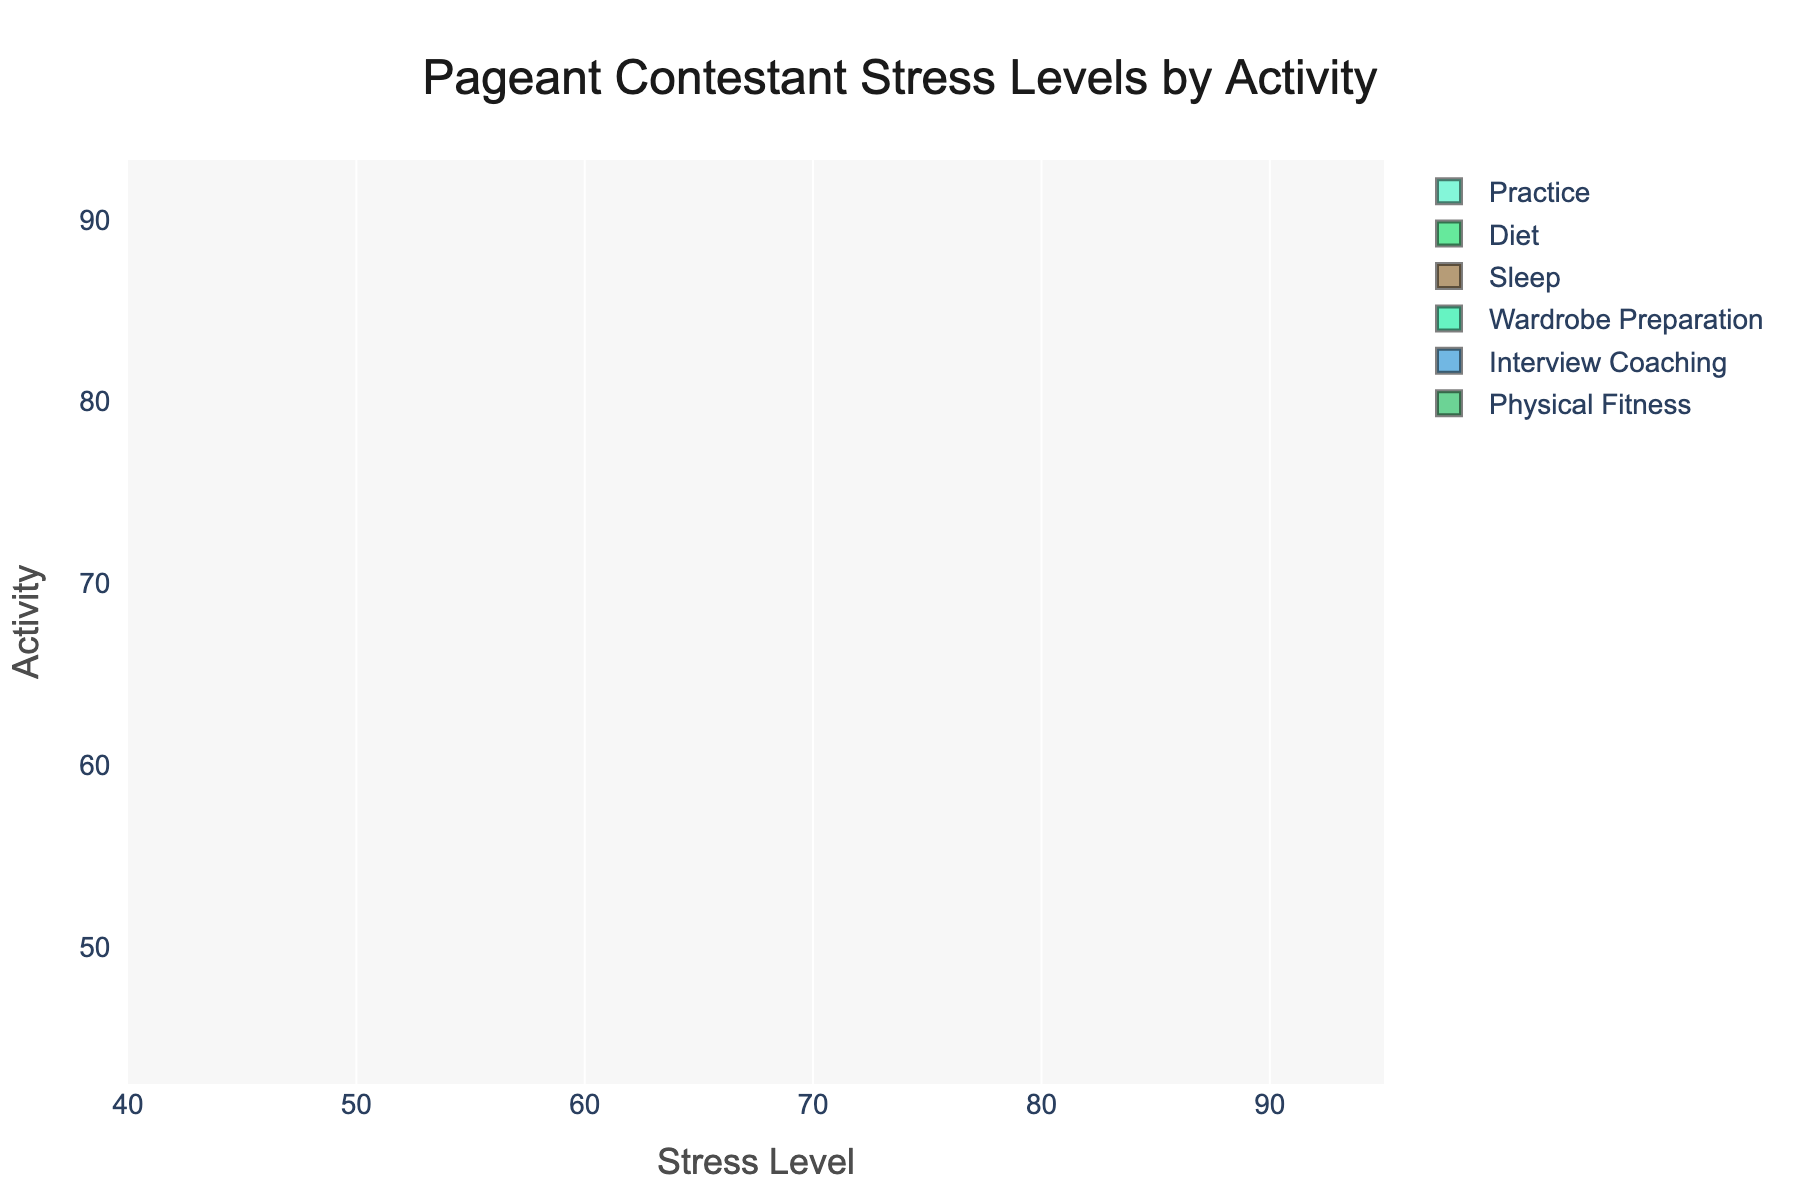what is the highest stress level recorded for wardrobe preparation activities? To find the highest stress level for wardrobe preparation activities, look for the topmost point of that specific violin chart. The highest value is 90.
Answer: 90 how many different preparation activities are shown in the chart? To determine the number of different preparation activities, count the unique labels on the y-axis of the violin chart. There are six distinct activities listed.
Answer: six which activity shows the lowest average stress level? Calculate the average stress level for each activity and identify the activity with the lowest value. Sleep has the lowest average stress level since all points are considerably lower compared to other activities.
Answer: sleep what is the main title of the plot? The main title is displayed at the top of the chart, setting the context for the visual data. It reads "Pageant Contestant Stress Levels by Activity."
Answer: Pageant Contestant Stress Levels by Activity does the practice activity show more variation in stress levels compared to diet? Observe the width and spread of the practice and diet violin charts. The practice violin chart is wider and shows a broader spread, indicating greater variation in stress levels compared to diet.
Answer: yes which activity has the most compact distribution of stress levels? Look at the uniformity and narrowness of the violin chart for each activity. Physical Fitness has a very compact distribution, meaning the stress levels are clustered closely together.
Answer: physical fitness what is the range of stress levels recorded for sleep activities? Find the lowest and highest points on the sleep violin chart. The range spans from 45 to 52.
Answer: 45 to 52 which activity appears to cause the highest maximum stress? Locate the highest point across all violin charts to see which activity reaches the maximum stress level. Wardrobe Preparation has the highest maximum stress level of 90.
Answer: wardrobe preparation compare the average stress levels of practice and interview coaching. Calculate the average stress levels for both practices (near mid-80s) and interview coaching (low 80s). Practice has a higher average stress level.
Answer: practice higher than interview coaching which corresponding activity has points extending beyond the average widening of figures? Identify the points that appear outside the main bulk of the violin plot. Both Wardrobe Preparation and Practice show more stress points extending outwards, indicating outliers or more considerable variability.
Answer: wardrobe preparation and practice 